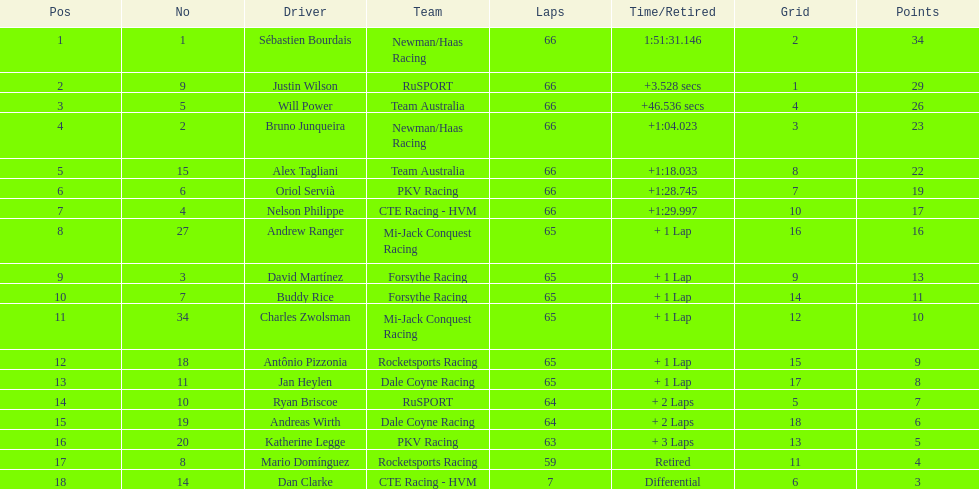At the 2006 gran premio telmex, who finished last? Dan Clarke. 